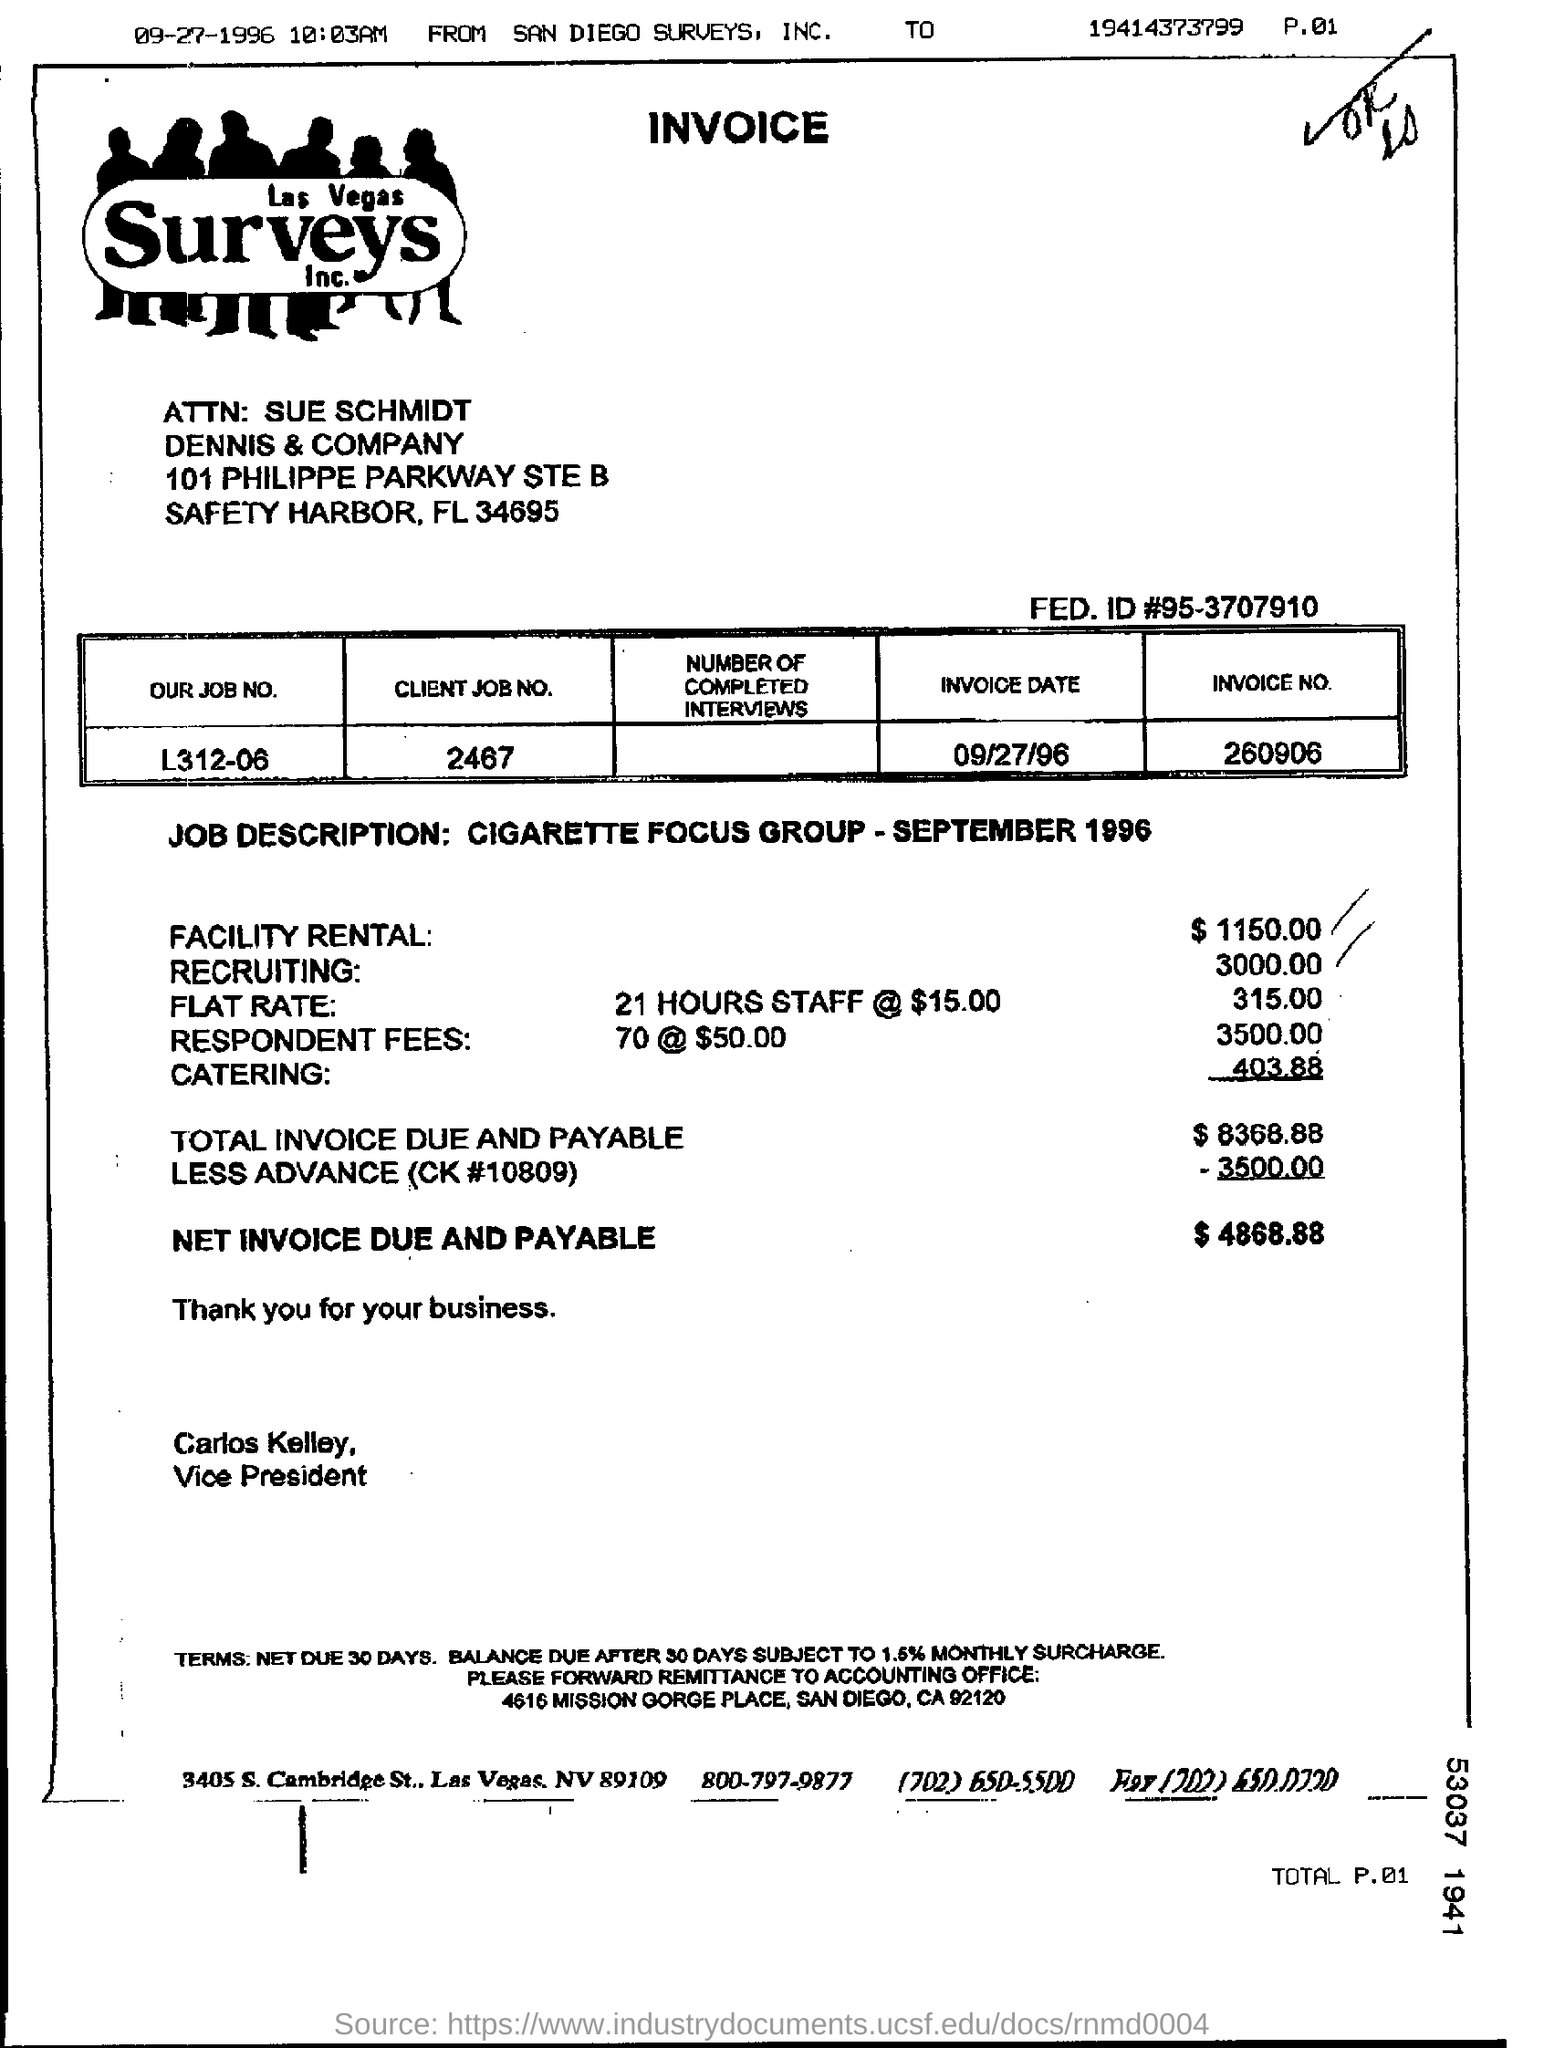Mention a couple of crucial points in this snapshot. Please indicate the client job number listed on the invoice, which is 2467... The invoice date according to the document is September 27, 1996. The invoice number mentioned in this document is 260906.. The invoice due and payable amount is $4868.88. The Facility Rental costs $1150.00. 